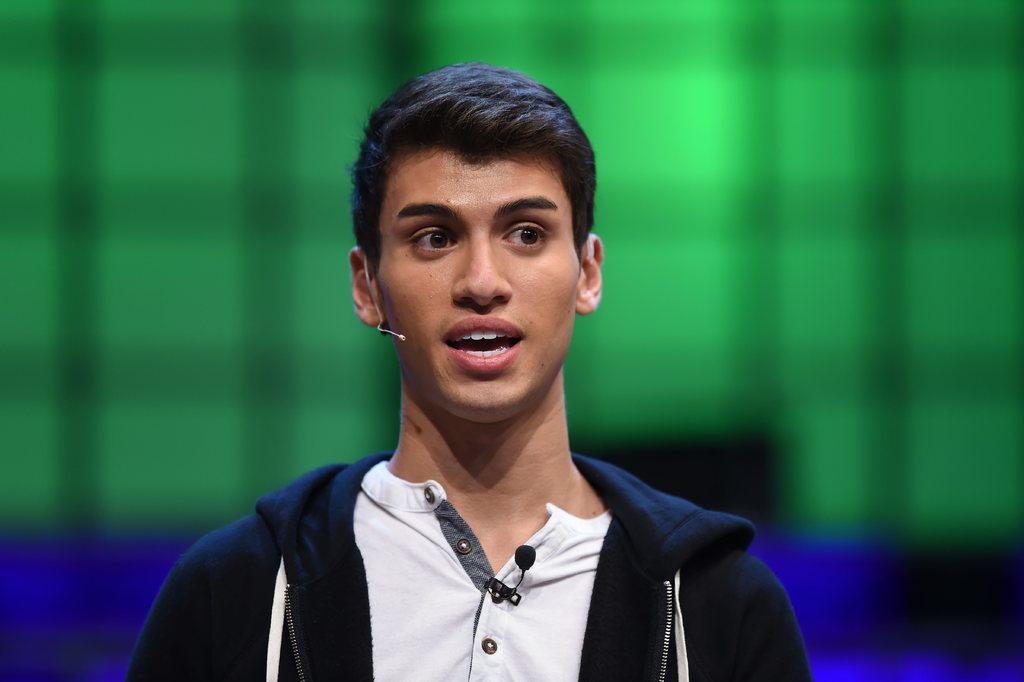Please provide a concise description of this image. In this picture we can see a man is speaking something, he wore a jacket, we can see a microphone on his t-shirt, there is a blurry background. 